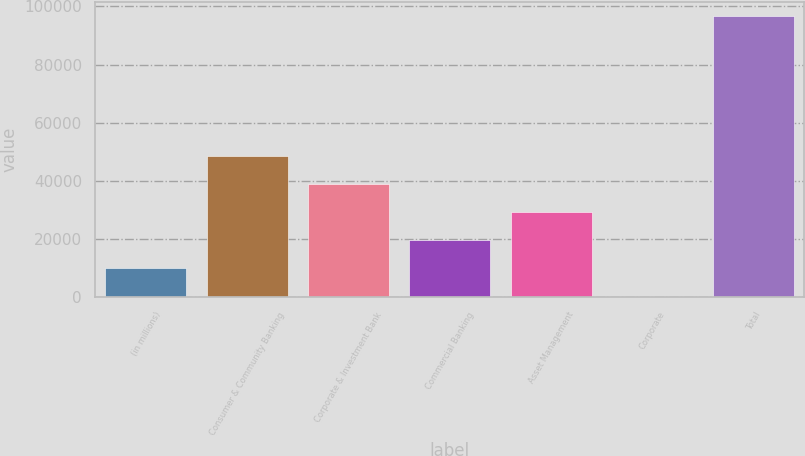<chart> <loc_0><loc_0><loc_500><loc_500><bar_chart><fcel>(in millions)<fcel>Consumer & Community Banking<fcel>Corporate & Investment Bank<fcel>Commercial Banking<fcel>Asset Management<fcel>Corporate<fcel>Total<nl><fcel>9903.6<fcel>48450<fcel>38813.4<fcel>19540.2<fcel>29176.8<fcel>267<fcel>96633<nl></chart> 